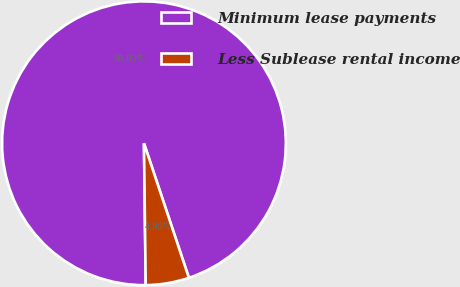Convert chart to OTSL. <chart><loc_0><loc_0><loc_500><loc_500><pie_chart><fcel>Minimum lease payments<fcel>Less Sublease rental income<nl><fcel>95.07%<fcel>4.93%<nl></chart> 